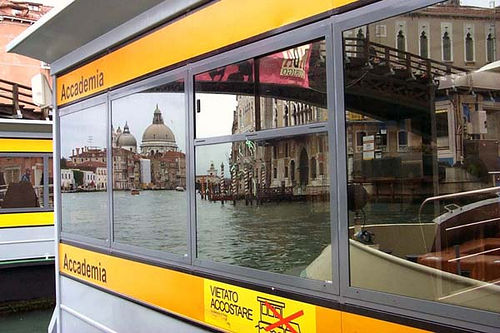Please transcribe the text information in this image. Accademia Accademia VETATO ACCOSTARE 